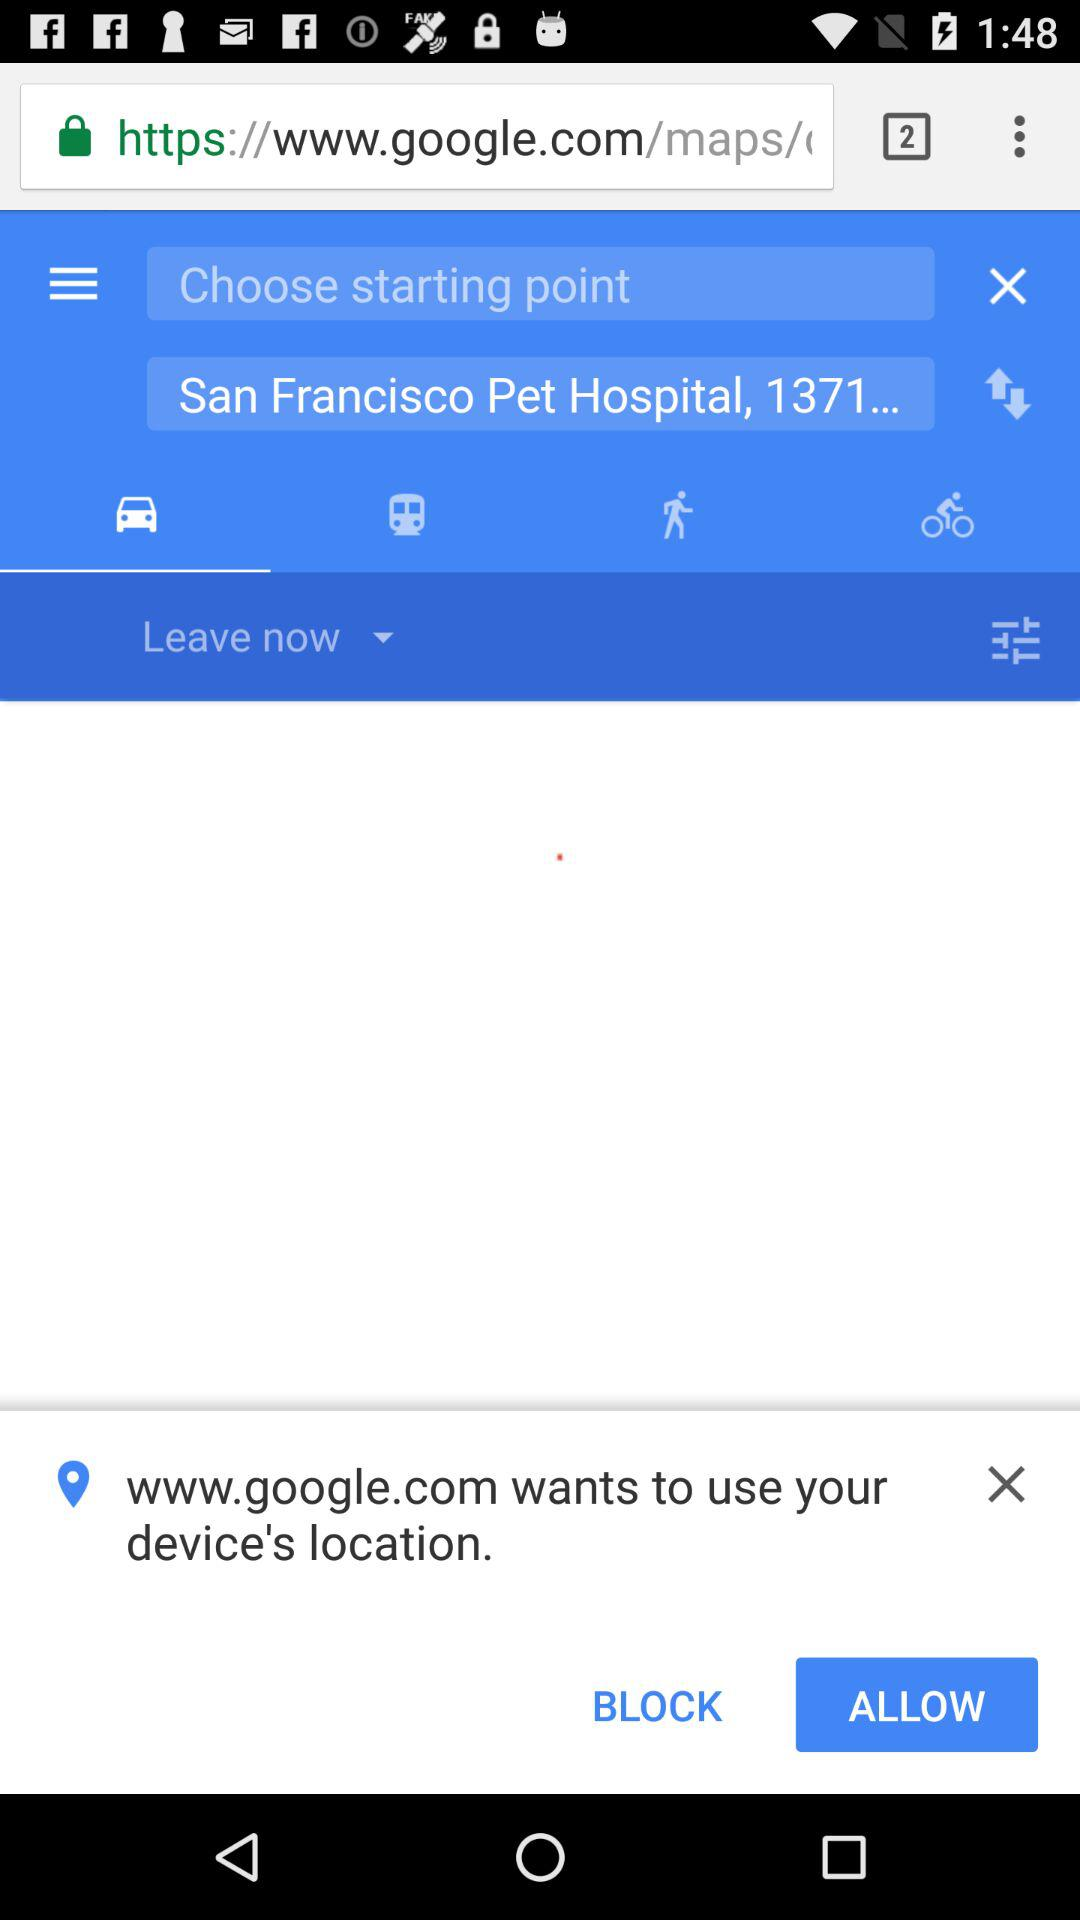Which tab has been selected? The selected tab is "Drive". 